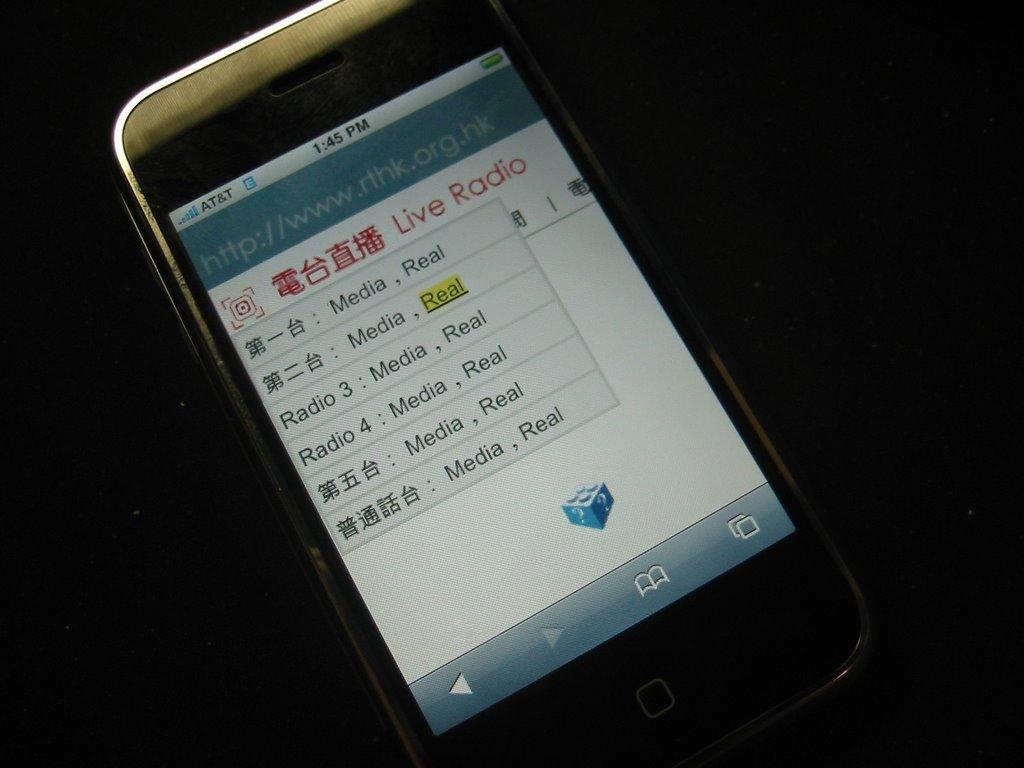<image>
Write a terse but informative summary of the picture. A picture of a cell phone with a list of different radio stations. 